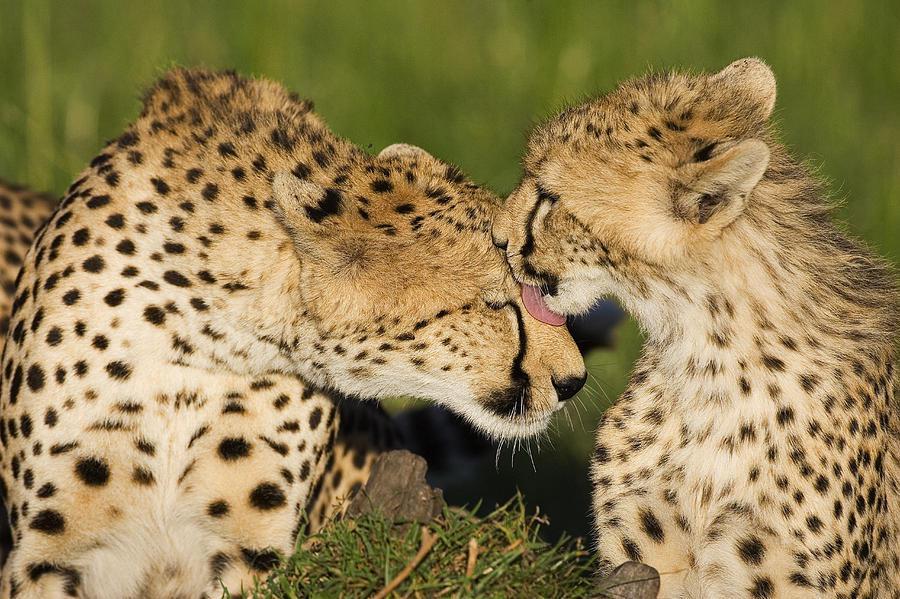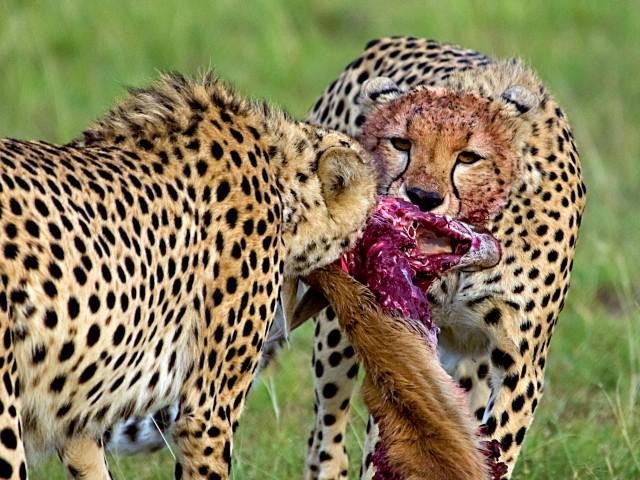The first image is the image on the left, the second image is the image on the right. Evaluate the accuracy of this statement regarding the images: "The left image contains a cheetah licking another cheetah.". Is it true? Answer yes or no. Yes. The first image is the image on the left, the second image is the image on the right. Given the left and right images, does the statement "An image shows one spotted wild cat licking the face of another wild cat." hold true? Answer yes or no. Yes. 